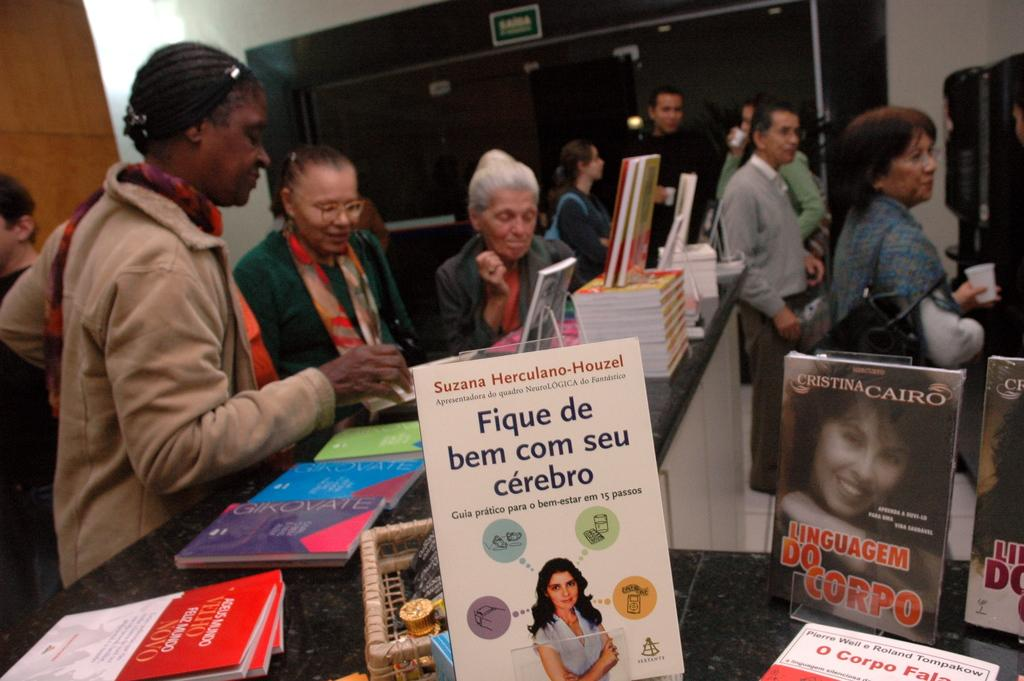<image>
Share a concise interpretation of the image provided. Many people at a book store looking at books in other languages 